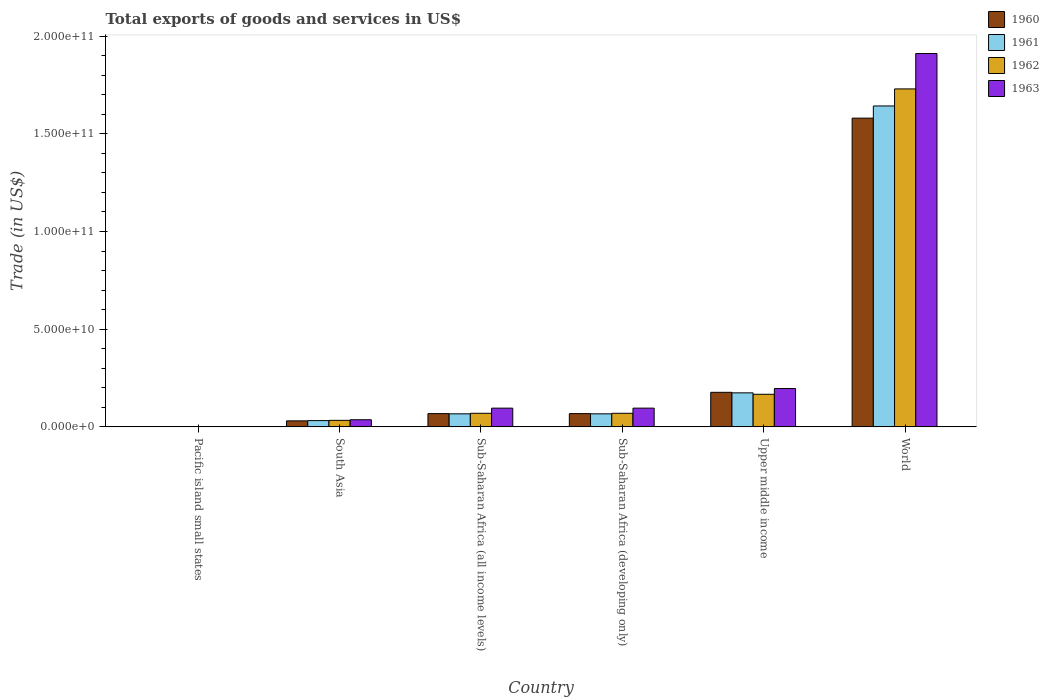How many different coloured bars are there?
Your response must be concise. 4. Are the number of bars per tick equal to the number of legend labels?
Your response must be concise. Yes. How many bars are there on the 2nd tick from the right?
Provide a succinct answer. 4. What is the label of the 6th group of bars from the left?
Ensure brevity in your answer.  World. In how many cases, is the number of bars for a given country not equal to the number of legend labels?
Your answer should be compact. 0. What is the total exports of goods and services in 1960 in South Asia?
Provide a succinct answer. 3.08e+09. Across all countries, what is the maximum total exports of goods and services in 1963?
Your answer should be very brief. 1.91e+11. Across all countries, what is the minimum total exports of goods and services in 1962?
Your answer should be compact. 6.29e+07. In which country was the total exports of goods and services in 1961 minimum?
Offer a very short reply. Pacific island small states. What is the total total exports of goods and services in 1960 in the graph?
Your answer should be very brief. 1.92e+11. What is the difference between the total exports of goods and services in 1962 in Pacific island small states and that in Sub-Saharan Africa (all income levels)?
Your answer should be compact. -6.89e+09. What is the difference between the total exports of goods and services in 1962 in Sub-Saharan Africa (all income levels) and the total exports of goods and services in 1963 in World?
Keep it short and to the point. -1.84e+11. What is the average total exports of goods and services in 1963 per country?
Your answer should be compact. 3.89e+1. What is the difference between the total exports of goods and services of/in 1963 and total exports of goods and services of/in 1960 in South Asia?
Your answer should be compact. 5.70e+08. In how many countries, is the total exports of goods and services in 1961 greater than 90000000000 US$?
Offer a terse response. 1. What is the ratio of the total exports of goods and services in 1960 in Sub-Saharan Africa (all income levels) to that in World?
Provide a short and direct response. 0.04. Is the total exports of goods and services in 1961 in Pacific island small states less than that in Upper middle income?
Make the answer very short. Yes. Is the difference between the total exports of goods and services in 1963 in Sub-Saharan Africa (all income levels) and Sub-Saharan Africa (developing only) greater than the difference between the total exports of goods and services in 1960 in Sub-Saharan Africa (all income levels) and Sub-Saharan Africa (developing only)?
Your answer should be very brief. No. What is the difference between the highest and the second highest total exports of goods and services in 1961?
Make the answer very short. -1.47e+11. What is the difference between the highest and the lowest total exports of goods and services in 1962?
Offer a very short reply. 1.73e+11. Is the sum of the total exports of goods and services in 1960 in Pacific island small states and South Asia greater than the maximum total exports of goods and services in 1963 across all countries?
Provide a short and direct response. No. Is it the case that in every country, the sum of the total exports of goods and services in 1960 and total exports of goods and services in 1963 is greater than the total exports of goods and services in 1962?
Provide a short and direct response. Yes. How many bars are there?
Your response must be concise. 24. Are all the bars in the graph horizontal?
Your answer should be compact. No. How many countries are there in the graph?
Offer a terse response. 6. Does the graph contain any zero values?
Provide a short and direct response. No. Where does the legend appear in the graph?
Offer a very short reply. Top right. How are the legend labels stacked?
Keep it short and to the point. Vertical. What is the title of the graph?
Make the answer very short. Total exports of goods and services in US$. What is the label or title of the X-axis?
Provide a short and direct response. Country. What is the label or title of the Y-axis?
Your response must be concise. Trade (in US$). What is the Trade (in US$) in 1960 in Pacific island small states?
Your answer should be compact. 6.15e+07. What is the Trade (in US$) in 1961 in Pacific island small states?
Offer a very short reply. 5.15e+07. What is the Trade (in US$) of 1962 in Pacific island small states?
Provide a short and direct response. 6.29e+07. What is the Trade (in US$) of 1963 in Pacific island small states?
Provide a short and direct response. 9.49e+07. What is the Trade (in US$) of 1960 in South Asia?
Your answer should be very brief. 3.08e+09. What is the Trade (in US$) of 1961 in South Asia?
Make the answer very short. 3.21e+09. What is the Trade (in US$) in 1962 in South Asia?
Give a very brief answer. 3.33e+09. What is the Trade (in US$) of 1963 in South Asia?
Your answer should be compact. 3.65e+09. What is the Trade (in US$) in 1960 in Sub-Saharan Africa (all income levels)?
Offer a very short reply. 6.78e+09. What is the Trade (in US$) of 1961 in Sub-Saharan Africa (all income levels)?
Keep it short and to the point. 6.67e+09. What is the Trade (in US$) in 1962 in Sub-Saharan Africa (all income levels)?
Keep it short and to the point. 6.95e+09. What is the Trade (in US$) in 1963 in Sub-Saharan Africa (all income levels)?
Provide a short and direct response. 9.58e+09. What is the Trade (in US$) of 1960 in Sub-Saharan Africa (developing only)?
Your answer should be compact. 6.78e+09. What is the Trade (in US$) in 1961 in Sub-Saharan Africa (developing only)?
Ensure brevity in your answer.  6.68e+09. What is the Trade (in US$) of 1962 in Sub-Saharan Africa (developing only)?
Keep it short and to the point. 6.95e+09. What is the Trade (in US$) in 1963 in Sub-Saharan Africa (developing only)?
Your answer should be very brief. 9.59e+09. What is the Trade (in US$) of 1960 in Upper middle income?
Offer a very short reply. 1.77e+1. What is the Trade (in US$) in 1961 in Upper middle income?
Give a very brief answer. 1.74e+1. What is the Trade (in US$) of 1962 in Upper middle income?
Provide a succinct answer. 1.67e+1. What is the Trade (in US$) of 1963 in Upper middle income?
Offer a very short reply. 1.96e+1. What is the Trade (in US$) in 1960 in World?
Provide a succinct answer. 1.58e+11. What is the Trade (in US$) of 1961 in World?
Keep it short and to the point. 1.64e+11. What is the Trade (in US$) in 1962 in World?
Your answer should be compact. 1.73e+11. What is the Trade (in US$) of 1963 in World?
Give a very brief answer. 1.91e+11. Across all countries, what is the maximum Trade (in US$) of 1960?
Make the answer very short. 1.58e+11. Across all countries, what is the maximum Trade (in US$) of 1961?
Ensure brevity in your answer.  1.64e+11. Across all countries, what is the maximum Trade (in US$) in 1962?
Offer a very short reply. 1.73e+11. Across all countries, what is the maximum Trade (in US$) in 1963?
Your answer should be compact. 1.91e+11. Across all countries, what is the minimum Trade (in US$) of 1960?
Your answer should be very brief. 6.15e+07. Across all countries, what is the minimum Trade (in US$) of 1961?
Offer a very short reply. 5.15e+07. Across all countries, what is the minimum Trade (in US$) of 1962?
Make the answer very short. 6.29e+07. Across all countries, what is the minimum Trade (in US$) of 1963?
Give a very brief answer. 9.49e+07. What is the total Trade (in US$) of 1960 in the graph?
Offer a very short reply. 1.92e+11. What is the total Trade (in US$) in 1961 in the graph?
Ensure brevity in your answer.  1.98e+11. What is the total Trade (in US$) in 1962 in the graph?
Provide a short and direct response. 2.07e+11. What is the total Trade (in US$) of 1963 in the graph?
Provide a short and direct response. 2.34e+11. What is the difference between the Trade (in US$) of 1960 in Pacific island small states and that in South Asia?
Your response must be concise. -3.01e+09. What is the difference between the Trade (in US$) in 1961 in Pacific island small states and that in South Asia?
Keep it short and to the point. -3.16e+09. What is the difference between the Trade (in US$) of 1962 in Pacific island small states and that in South Asia?
Offer a terse response. -3.27e+09. What is the difference between the Trade (in US$) of 1963 in Pacific island small states and that in South Asia?
Your answer should be compact. -3.55e+09. What is the difference between the Trade (in US$) in 1960 in Pacific island small states and that in Sub-Saharan Africa (all income levels)?
Make the answer very short. -6.72e+09. What is the difference between the Trade (in US$) of 1961 in Pacific island small states and that in Sub-Saharan Africa (all income levels)?
Keep it short and to the point. -6.62e+09. What is the difference between the Trade (in US$) in 1962 in Pacific island small states and that in Sub-Saharan Africa (all income levels)?
Offer a terse response. -6.89e+09. What is the difference between the Trade (in US$) in 1963 in Pacific island small states and that in Sub-Saharan Africa (all income levels)?
Make the answer very short. -9.49e+09. What is the difference between the Trade (in US$) in 1960 in Pacific island small states and that in Sub-Saharan Africa (developing only)?
Keep it short and to the point. -6.72e+09. What is the difference between the Trade (in US$) in 1961 in Pacific island small states and that in Sub-Saharan Africa (developing only)?
Your answer should be compact. -6.62e+09. What is the difference between the Trade (in US$) of 1962 in Pacific island small states and that in Sub-Saharan Africa (developing only)?
Offer a very short reply. -6.89e+09. What is the difference between the Trade (in US$) in 1963 in Pacific island small states and that in Sub-Saharan Africa (developing only)?
Keep it short and to the point. -9.49e+09. What is the difference between the Trade (in US$) in 1960 in Pacific island small states and that in Upper middle income?
Keep it short and to the point. -1.76e+1. What is the difference between the Trade (in US$) in 1961 in Pacific island small states and that in Upper middle income?
Give a very brief answer. -1.74e+1. What is the difference between the Trade (in US$) of 1962 in Pacific island small states and that in Upper middle income?
Offer a very short reply. -1.66e+1. What is the difference between the Trade (in US$) of 1963 in Pacific island small states and that in Upper middle income?
Your answer should be very brief. -1.95e+1. What is the difference between the Trade (in US$) of 1960 in Pacific island small states and that in World?
Your response must be concise. -1.58e+11. What is the difference between the Trade (in US$) of 1961 in Pacific island small states and that in World?
Your response must be concise. -1.64e+11. What is the difference between the Trade (in US$) in 1962 in Pacific island small states and that in World?
Provide a short and direct response. -1.73e+11. What is the difference between the Trade (in US$) of 1963 in Pacific island small states and that in World?
Offer a very short reply. -1.91e+11. What is the difference between the Trade (in US$) of 1960 in South Asia and that in Sub-Saharan Africa (all income levels)?
Provide a short and direct response. -3.71e+09. What is the difference between the Trade (in US$) in 1961 in South Asia and that in Sub-Saharan Africa (all income levels)?
Give a very brief answer. -3.47e+09. What is the difference between the Trade (in US$) in 1962 in South Asia and that in Sub-Saharan Africa (all income levels)?
Make the answer very short. -3.62e+09. What is the difference between the Trade (in US$) of 1963 in South Asia and that in Sub-Saharan Africa (all income levels)?
Offer a terse response. -5.94e+09. What is the difference between the Trade (in US$) of 1960 in South Asia and that in Sub-Saharan Africa (developing only)?
Make the answer very short. -3.71e+09. What is the difference between the Trade (in US$) of 1961 in South Asia and that in Sub-Saharan Africa (developing only)?
Give a very brief answer. -3.47e+09. What is the difference between the Trade (in US$) of 1962 in South Asia and that in Sub-Saharan Africa (developing only)?
Your answer should be compact. -3.62e+09. What is the difference between the Trade (in US$) of 1963 in South Asia and that in Sub-Saharan Africa (developing only)?
Make the answer very short. -5.94e+09. What is the difference between the Trade (in US$) in 1960 in South Asia and that in Upper middle income?
Your answer should be very brief. -1.46e+1. What is the difference between the Trade (in US$) in 1961 in South Asia and that in Upper middle income?
Make the answer very short. -1.42e+1. What is the difference between the Trade (in US$) in 1962 in South Asia and that in Upper middle income?
Your answer should be very brief. -1.33e+1. What is the difference between the Trade (in US$) in 1963 in South Asia and that in Upper middle income?
Offer a terse response. -1.60e+1. What is the difference between the Trade (in US$) of 1960 in South Asia and that in World?
Keep it short and to the point. -1.55e+11. What is the difference between the Trade (in US$) in 1961 in South Asia and that in World?
Offer a very short reply. -1.61e+11. What is the difference between the Trade (in US$) in 1962 in South Asia and that in World?
Give a very brief answer. -1.70e+11. What is the difference between the Trade (in US$) in 1963 in South Asia and that in World?
Provide a short and direct response. -1.87e+11. What is the difference between the Trade (in US$) of 1960 in Sub-Saharan Africa (all income levels) and that in Sub-Saharan Africa (developing only)?
Ensure brevity in your answer.  -1.83e+06. What is the difference between the Trade (in US$) of 1961 in Sub-Saharan Africa (all income levels) and that in Sub-Saharan Africa (developing only)?
Provide a short and direct response. -1.80e+06. What is the difference between the Trade (in US$) of 1962 in Sub-Saharan Africa (all income levels) and that in Sub-Saharan Africa (developing only)?
Ensure brevity in your answer.  -1.87e+06. What is the difference between the Trade (in US$) of 1963 in Sub-Saharan Africa (all income levels) and that in Sub-Saharan Africa (developing only)?
Offer a terse response. -4.80e+06. What is the difference between the Trade (in US$) of 1960 in Sub-Saharan Africa (all income levels) and that in Upper middle income?
Make the answer very short. -1.09e+1. What is the difference between the Trade (in US$) of 1961 in Sub-Saharan Africa (all income levels) and that in Upper middle income?
Your answer should be very brief. -1.07e+1. What is the difference between the Trade (in US$) of 1962 in Sub-Saharan Africa (all income levels) and that in Upper middle income?
Keep it short and to the point. -9.72e+09. What is the difference between the Trade (in US$) of 1963 in Sub-Saharan Africa (all income levels) and that in Upper middle income?
Give a very brief answer. -1.00e+1. What is the difference between the Trade (in US$) of 1960 in Sub-Saharan Africa (all income levels) and that in World?
Make the answer very short. -1.51e+11. What is the difference between the Trade (in US$) in 1961 in Sub-Saharan Africa (all income levels) and that in World?
Make the answer very short. -1.58e+11. What is the difference between the Trade (in US$) in 1962 in Sub-Saharan Africa (all income levels) and that in World?
Provide a succinct answer. -1.66e+11. What is the difference between the Trade (in US$) in 1963 in Sub-Saharan Africa (all income levels) and that in World?
Give a very brief answer. -1.81e+11. What is the difference between the Trade (in US$) of 1960 in Sub-Saharan Africa (developing only) and that in Upper middle income?
Provide a short and direct response. -1.09e+1. What is the difference between the Trade (in US$) of 1961 in Sub-Saharan Africa (developing only) and that in Upper middle income?
Ensure brevity in your answer.  -1.07e+1. What is the difference between the Trade (in US$) of 1962 in Sub-Saharan Africa (developing only) and that in Upper middle income?
Offer a very short reply. -9.72e+09. What is the difference between the Trade (in US$) of 1963 in Sub-Saharan Africa (developing only) and that in Upper middle income?
Provide a short and direct response. -1.00e+1. What is the difference between the Trade (in US$) of 1960 in Sub-Saharan Africa (developing only) and that in World?
Make the answer very short. -1.51e+11. What is the difference between the Trade (in US$) of 1961 in Sub-Saharan Africa (developing only) and that in World?
Keep it short and to the point. -1.58e+11. What is the difference between the Trade (in US$) in 1962 in Sub-Saharan Africa (developing only) and that in World?
Make the answer very short. -1.66e+11. What is the difference between the Trade (in US$) in 1963 in Sub-Saharan Africa (developing only) and that in World?
Your response must be concise. -1.81e+11. What is the difference between the Trade (in US$) of 1960 in Upper middle income and that in World?
Ensure brevity in your answer.  -1.40e+11. What is the difference between the Trade (in US$) of 1961 in Upper middle income and that in World?
Provide a short and direct response. -1.47e+11. What is the difference between the Trade (in US$) in 1962 in Upper middle income and that in World?
Your answer should be very brief. -1.56e+11. What is the difference between the Trade (in US$) of 1963 in Upper middle income and that in World?
Your answer should be very brief. -1.71e+11. What is the difference between the Trade (in US$) of 1960 in Pacific island small states and the Trade (in US$) of 1961 in South Asia?
Offer a terse response. -3.15e+09. What is the difference between the Trade (in US$) of 1960 in Pacific island small states and the Trade (in US$) of 1962 in South Asia?
Offer a very short reply. -3.27e+09. What is the difference between the Trade (in US$) in 1960 in Pacific island small states and the Trade (in US$) in 1963 in South Asia?
Ensure brevity in your answer.  -3.58e+09. What is the difference between the Trade (in US$) of 1961 in Pacific island small states and the Trade (in US$) of 1962 in South Asia?
Keep it short and to the point. -3.28e+09. What is the difference between the Trade (in US$) of 1961 in Pacific island small states and the Trade (in US$) of 1963 in South Asia?
Give a very brief answer. -3.59e+09. What is the difference between the Trade (in US$) in 1962 in Pacific island small states and the Trade (in US$) in 1963 in South Asia?
Provide a short and direct response. -3.58e+09. What is the difference between the Trade (in US$) in 1960 in Pacific island small states and the Trade (in US$) in 1961 in Sub-Saharan Africa (all income levels)?
Ensure brevity in your answer.  -6.61e+09. What is the difference between the Trade (in US$) of 1960 in Pacific island small states and the Trade (in US$) of 1962 in Sub-Saharan Africa (all income levels)?
Keep it short and to the point. -6.89e+09. What is the difference between the Trade (in US$) in 1960 in Pacific island small states and the Trade (in US$) in 1963 in Sub-Saharan Africa (all income levels)?
Give a very brief answer. -9.52e+09. What is the difference between the Trade (in US$) of 1961 in Pacific island small states and the Trade (in US$) of 1962 in Sub-Saharan Africa (all income levels)?
Your answer should be very brief. -6.90e+09. What is the difference between the Trade (in US$) in 1961 in Pacific island small states and the Trade (in US$) in 1963 in Sub-Saharan Africa (all income levels)?
Your response must be concise. -9.53e+09. What is the difference between the Trade (in US$) in 1962 in Pacific island small states and the Trade (in US$) in 1963 in Sub-Saharan Africa (all income levels)?
Offer a terse response. -9.52e+09. What is the difference between the Trade (in US$) of 1960 in Pacific island small states and the Trade (in US$) of 1961 in Sub-Saharan Africa (developing only)?
Provide a succinct answer. -6.61e+09. What is the difference between the Trade (in US$) in 1960 in Pacific island small states and the Trade (in US$) in 1962 in Sub-Saharan Africa (developing only)?
Keep it short and to the point. -6.89e+09. What is the difference between the Trade (in US$) in 1960 in Pacific island small states and the Trade (in US$) in 1963 in Sub-Saharan Africa (developing only)?
Provide a short and direct response. -9.53e+09. What is the difference between the Trade (in US$) in 1961 in Pacific island small states and the Trade (in US$) in 1962 in Sub-Saharan Africa (developing only)?
Your answer should be very brief. -6.90e+09. What is the difference between the Trade (in US$) in 1961 in Pacific island small states and the Trade (in US$) in 1963 in Sub-Saharan Africa (developing only)?
Provide a short and direct response. -9.54e+09. What is the difference between the Trade (in US$) of 1962 in Pacific island small states and the Trade (in US$) of 1963 in Sub-Saharan Africa (developing only)?
Provide a short and direct response. -9.52e+09. What is the difference between the Trade (in US$) of 1960 in Pacific island small states and the Trade (in US$) of 1961 in Upper middle income?
Ensure brevity in your answer.  -1.74e+1. What is the difference between the Trade (in US$) in 1960 in Pacific island small states and the Trade (in US$) in 1962 in Upper middle income?
Keep it short and to the point. -1.66e+1. What is the difference between the Trade (in US$) in 1960 in Pacific island small states and the Trade (in US$) in 1963 in Upper middle income?
Offer a terse response. -1.96e+1. What is the difference between the Trade (in US$) in 1961 in Pacific island small states and the Trade (in US$) in 1962 in Upper middle income?
Give a very brief answer. -1.66e+1. What is the difference between the Trade (in US$) of 1961 in Pacific island small states and the Trade (in US$) of 1963 in Upper middle income?
Your answer should be very brief. -1.96e+1. What is the difference between the Trade (in US$) of 1962 in Pacific island small states and the Trade (in US$) of 1963 in Upper middle income?
Give a very brief answer. -1.96e+1. What is the difference between the Trade (in US$) of 1960 in Pacific island small states and the Trade (in US$) of 1961 in World?
Provide a short and direct response. -1.64e+11. What is the difference between the Trade (in US$) of 1960 in Pacific island small states and the Trade (in US$) of 1962 in World?
Keep it short and to the point. -1.73e+11. What is the difference between the Trade (in US$) of 1960 in Pacific island small states and the Trade (in US$) of 1963 in World?
Your answer should be very brief. -1.91e+11. What is the difference between the Trade (in US$) of 1961 in Pacific island small states and the Trade (in US$) of 1962 in World?
Your answer should be compact. -1.73e+11. What is the difference between the Trade (in US$) of 1961 in Pacific island small states and the Trade (in US$) of 1963 in World?
Provide a succinct answer. -1.91e+11. What is the difference between the Trade (in US$) in 1962 in Pacific island small states and the Trade (in US$) in 1963 in World?
Your answer should be compact. -1.91e+11. What is the difference between the Trade (in US$) in 1960 in South Asia and the Trade (in US$) in 1961 in Sub-Saharan Africa (all income levels)?
Make the answer very short. -3.60e+09. What is the difference between the Trade (in US$) in 1960 in South Asia and the Trade (in US$) in 1962 in Sub-Saharan Africa (all income levels)?
Offer a terse response. -3.88e+09. What is the difference between the Trade (in US$) in 1960 in South Asia and the Trade (in US$) in 1963 in Sub-Saharan Africa (all income levels)?
Your answer should be very brief. -6.51e+09. What is the difference between the Trade (in US$) of 1961 in South Asia and the Trade (in US$) of 1962 in Sub-Saharan Africa (all income levels)?
Your answer should be very brief. -3.74e+09. What is the difference between the Trade (in US$) of 1961 in South Asia and the Trade (in US$) of 1963 in Sub-Saharan Africa (all income levels)?
Provide a short and direct response. -6.37e+09. What is the difference between the Trade (in US$) in 1962 in South Asia and the Trade (in US$) in 1963 in Sub-Saharan Africa (all income levels)?
Your answer should be compact. -6.25e+09. What is the difference between the Trade (in US$) in 1960 in South Asia and the Trade (in US$) in 1961 in Sub-Saharan Africa (developing only)?
Ensure brevity in your answer.  -3.60e+09. What is the difference between the Trade (in US$) in 1960 in South Asia and the Trade (in US$) in 1962 in Sub-Saharan Africa (developing only)?
Your answer should be very brief. -3.88e+09. What is the difference between the Trade (in US$) in 1960 in South Asia and the Trade (in US$) in 1963 in Sub-Saharan Africa (developing only)?
Make the answer very short. -6.51e+09. What is the difference between the Trade (in US$) in 1961 in South Asia and the Trade (in US$) in 1962 in Sub-Saharan Africa (developing only)?
Ensure brevity in your answer.  -3.75e+09. What is the difference between the Trade (in US$) in 1961 in South Asia and the Trade (in US$) in 1963 in Sub-Saharan Africa (developing only)?
Offer a terse response. -6.38e+09. What is the difference between the Trade (in US$) of 1962 in South Asia and the Trade (in US$) of 1963 in Sub-Saharan Africa (developing only)?
Give a very brief answer. -6.25e+09. What is the difference between the Trade (in US$) in 1960 in South Asia and the Trade (in US$) in 1961 in Upper middle income?
Make the answer very short. -1.43e+1. What is the difference between the Trade (in US$) of 1960 in South Asia and the Trade (in US$) of 1962 in Upper middle income?
Provide a succinct answer. -1.36e+1. What is the difference between the Trade (in US$) of 1960 in South Asia and the Trade (in US$) of 1963 in Upper middle income?
Make the answer very short. -1.65e+1. What is the difference between the Trade (in US$) in 1961 in South Asia and the Trade (in US$) in 1962 in Upper middle income?
Your response must be concise. -1.35e+1. What is the difference between the Trade (in US$) in 1961 in South Asia and the Trade (in US$) in 1963 in Upper middle income?
Your answer should be compact. -1.64e+1. What is the difference between the Trade (in US$) of 1962 in South Asia and the Trade (in US$) of 1963 in Upper middle income?
Make the answer very short. -1.63e+1. What is the difference between the Trade (in US$) in 1960 in South Asia and the Trade (in US$) in 1961 in World?
Make the answer very short. -1.61e+11. What is the difference between the Trade (in US$) in 1960 in South Asia and the Trade (in US$) in 1962 in World?
Offer a terse response. -1.70e+11. What is the difference between the Trade (in US$) in 1960 in South Asia and the Trade (in US$) in 1963 in World?
Your answer should be compact. -1.88e+11. What is the difference between the Trade (in US$) in 1961 in South Asia and the Trade (in US$) in 1962 in World?
Make the answer very short. -1.70e+11. What is the difference between the Trade (in US$) of 1961 in South Asia and the Trade (in US$) of 1963 in World?
Your answer should be very brief. -1.88e+11. What is the difference between the Trade (in US$) in 1962 in South Asia and the Trade (in US$) in 1963 in World?
Keep it short and to the point. -1.88e+11. What is the difference between the Trade (in US$) of 1960 in Sub-Saharan Africa (all income levels) and the Trade (in US$) of 1961 in Sub-Saharan Africa (developing only)?
Give a very brief answer. 1.06e+08. What is the difference between the Trade (in US$) in 1960 in Sub-Saharan Africa (all income levels) and the Trade (in US$) in 1962 in Sub-Saharan Africa (developing only)?
Your response must be concise. -1.73e+08. What is the difference between the Trade (in US$) in 1960 in Sub-Saharan Africa (all income levels) and the Trade (in US$) in 1963 in Sub-Saharan Africa (developing only)?
Your response must be concise. -2.81e+09. What is the difference between the Trade (in US$) of 1961 in Sub-Saharan Africa (all income levels) and the Trade (in US$) of 1962 in Sub-Saharan Africa (developing only)?
Provide a short and direct response. -2.81e+08. What is the difference between the Trade (in US$) in 1961 in Sub-Saharan Africa (all income levels) and the Trade (in US$) in 1963 in Sub-Saharan Africa (developing only)?
Your answer should be very brief. -2.91e+09. What is the difference between the Trade (in US$) in 1962 in Sub-Saharan Africa (all income levels) and the Trade (in US$) in 1963 in Sub-Saharan Africa (developing only)?
Offer a very short reply. -2.63e+09. What is the difference between the Trade (in US$) in 1960 in Sub-Saharan Africa (all income levels) and the Trade (in US$) in 1961 in Upper middle income?
Provide a succinct answer. -1.06e+1. What is the difference between the Trade (in US$) in 1960 in Sub-Saharan Africa (all income levels) and the Trade (in US$) in 1962 in Upper middle income?
Your answer should be very brief. -9.89e+09. What is the difference between the Trade (in US$) in 1960 in Sub-Saharan Africa (all income levels) and the Trade (in US$) in 1963 in Upper middle income?
Your answer should be very brief. -1.28e+1. What is the difference between the Trade (in US$) of 1961 in Sub-Saharan Africa (all income levels) and the Trade (in US$) of 1962 in Upper middle income?
Your response must be concise. -1.00e+1. What is the difference between the Trade (in US$) in 1961 in Sub-Saharan Africa (all income levels) and the Trade (in US$) in 1963 in Upper middle income?
Give a very brief answer. -1.29e+1. What is the difference between the Trade (in US$) of 1962 in Sub-Saharan Africa (all income levels) and the Trade (in US$) of 1963 in Upper middle income?
Your response must be concise. -1.27e+1. What is the difference between the Trade (in US$) in 1960 in Sub-Saharan Africa (all income levels) and the Trade (in US$) in 1961 in World?
Your answer should be compact. -1.57e+11. What is the difference between the Trade (in US$) in 1960 in Sub-Saharan Africa (all income levels) and the Trade (in US$) in 1962 in World?
Ensure brevity in your answer.  -1.66e+11. What is the difference between the Trade (in US$) of 1960 in Sub-Saharan Africa (all income levels) and the Trade (in US$) of 1963 in World?
Provide a succinct answer. -1.84e+11. What is the difference between the Trade (in US$) in 1961 in Sub-Saharan Africa (all income levels) and the Trade (in US$) in 1962 in World?
Your answer should be very brief. -1.66e+11. What is the difference between the Trade (in US$) of 1961 in Sub-Saharan Africa (all income levels) and the Trade (in US$) of 1963 in World?
Ensure brevity in your answer.  -1.84e+11. What is the difference between the Trade (in US$) in 1962 in Sub-Saharan Africa (all income levels) and the Trade (in US$) in 1963 in World?
Provide a short and direct response. -1.84e+11. What is the difference between the Trade (in US$) of 1960 in Sub-Saharan Africa (developing only) and the Trade (in US$) of 1961 in Upper middle income?
Make the answer very short. -1.06e+1. What is the difference between the Trade (in US$) in 1960 in Sub-Saharan Africa (developing only) and the Trade (in US$) in 1962 in Upper middle income?
Keep it short and to the point. -9.89e+09. What is the difference between the Trade (in US$) in 1960 in Sub-Saharan Africa (developing only) and the Trade (in US$) in 1963 in Upper middle income?
Keep it short and to the point. -1.28e+1. What is the difference between the Trade (in US$) of 1961 in Sub-Saharan Africa (developing only) and the Trade (in US$) of 1962 in Upper middle income?
Your response must be concise. -1.00e+1. What is the difference between the Trade (in US$) of 1961 in Sub-Saharan Africa (developing only) and the Trade (in US$) of 1963 in Upper middle income?
Ensure brevity in your answer.  -1.29e+1. What is the difference between the Trade (in US$) of 1962 in Sub-Saharan Africa (developing only) and the Trade (in US$) of 1963 in Upper middle income?
Provide a short and direct response. -1.27e+1. What is the difference between the Trade (in US$) of 1960 in Sub-Saharan Africa (developing only) and the Trade (in US$) of 1961 in World?
Your answer should be compact. -1.57e+11. What is the difference between the Trade (in US$) of 1960 in Sub-Saharan Africa (developing only) and the Trade (in US$) of 1962 in World?
Keep it short and to the point. -1.66e+11. What is the difference between the Trade (in US$) in 1960 in Sub-Saharan Africa (developing only) and the Trade (in US$) in 1963 in World?
Give a very brief answer. -1.84e+11. What is the difference between the Trade (in US$) in 1961 in Sub-Saharan Africa (developing only) and the Trade (in US$) in 1962 in World?
Make the answer very short. -1.66e+11. What is the difference between the Trade (in US$) in 1961 in Sub-Saharan Africa (developing only) and the Trade (in US$) in 1963 in World?
Offer a very short reply. -1.84e+11. What is the difference between the Trade (in US$) in 1962 in Sub-Saharan Africa (developing only) and the Trade (in US$) in 1963 in World?
Give a very brief answer. -1.84e+11. What is the difference between the Trade (in US$) in 1960 in Upper middle income and the Trade (in US$) in 1961 in World?
Keep it short and to the point. -1.47e+11. What is the difference between the Trade (in US$) in 1960 in Upper middle income and the Trade (in US$) in 1962 in World?
Keep it short and to the point. -1.55e+11. What is the difference between the Trade (in US$) in 1960 in Upper middle income and the Trade (in US$) in 1963 in World?
Your answer should be compact. -1.73e+11. What is the difference between the Trade (in US$) of 1961 in Upper middle income and the Trade (in US$) of 1962 in World?
Provide a short and direct response. -1.56e+11. What is the difference between the Trade (in US$) of 1961 in Upper middle income and the Trade (in US$) of 1963 in World?
Offer a very short reply. -1.74e+11. What is the difference between the Trade (in US$) in 1962 in Upper middle income and the Trade (in US$) in 1963 in World?
Ensure brevity in your answer.  -1.74e+11. What is the average Trade (in US$) in 1960 per country?
Ensure brevity in your answer.  3.21e+1. What is the average Trade (in US$) of 1961 per country?
Your answer should be compact. 3.30e+1. What is the average Trade (in US$) of 1962 per country?
Your answer should be very brief. 3.45e+1. What is the average Trade (in US$) of 1963 per country?
Make the answer very short. 3.89e+1. What is the difference between the Trade (in US$) in 1960 and Trade (in US$) in 1961 in Pacific island small states?
Make the answer very short. 9.94e+06. What is the difference between the Trade (in US$) of 1960 and Trade (in US$) of 1962 in Pacific island small states?
Provide a succinct answer. -1.45e+06. What is the difference between the Trade (in US$) of 1960 and Trade (in US$) of 1963 in Pacific island small states?
Your response must be concise. -3.35e+07. What is the difference between the Trade (in US$) of 1961 and Trade (in US$) of 1962 in Pacific island small states?
Your answer should be compact. -1.14e+07. What is the difference between the Trade (in US$) of 1961 and Trade (in US$) of 1963 in Pacific island small states?
Offer a terse response. -4.34e+07. What is the difference between the Trade (in US$) of 1962 and Trade (in US$) of 1963 in Pacific island small states?
Keep it short and to the point. -3.20e+07. What is the difference between the Trade (in US$) of 1960 and Trade (in US$) of 1961 in South Asia?
Provide a short and direct response. -1.32e+08. What is the difference between the Trade (in US$) in 1960 and Trade (in US$) in 1962 in South Asia?
Your response must be concise. -2.57e+08. What is the difference between the Trade (in US$) in 1960 and Trade (in US$) in 1963 in South Asia?
Offer a terse response. -5.70e+08. What is the difference between the Trade (in US$) of 1961 and Trade (in US$) of 1962 in South Asia?
Provide a short and direct response. -1.26e+08. What is the difference between the Trade (in US$) of 1961 and Trade (in US$) of 1963 in South Asia?
Give a very brief answer. -4.38e+08. What is the difference between the Trade (in US$) in 1962 and Trade (in US$) in 1963 in South Asia?
Provide a short and direct response. -3.13e+08. What is the difference between the Trade (in US$) in 1960 and Trade (in US$) in 1961 in Sub-Saharan Africa (all income levels)?
Your answer should be compact. 1.08e+08. What is the difference between the Trade (in US$) in 1960 and Trade (in US$) in 1962 in Sub-Saharan Africa (all income levels)?
Keep it short and to the point. -1.71e+08. What is the difference between the Trade (in US$) of 1960 and Trade (in US$) of 1963 in Sub-Saharan Africa (all income levels)?
Make the answer very short. -2.80e+09. What is the difference between the Trade (in US$) of 1961 and Trade (in US$) of 1962 in Sub-Saharan Africa (all income levels)?
Offer a terse response. -2.79e+08. What is the difference between the Trade (in US$) of 1961 and Trade (in US$) of 1963 in Sub-Saharan Africa (all income levels)?
Give a very brief answer. -2.91e+09. What is the difference between the Trade (in US$) of 1962 and Trade (in US$) of 1963 in Sub-Saharan Africa (all income levels)?
Offer a very short reply. -2.63e+09. What is the difference between the Trade (in US$) of 1960 and Trade (in US$) of 1961 in Sub-Saharan Africa (developing only)?
Your response must be concise. 1.08e+08. What is the difference between the Trade (in US$) in 1960 and Trade (in US$) in 1962 in Sub-Saharan Africa (developing only)?
Your response must be concise. -1.71e+08. What is the difference between the Trade (in US$) of 1960 and Trade (in US$) of 1963 in Sub-Saharan Africa (developing only)?
Keep it short and to the point. -2.80e+09. What is the difference between the Trade (in US$) in 1961 and Trade (in US$) in 1962 in Sub-Saharan Africa (developing only)?
Provide a short and direct response. -2.79e+08. What is the difference between the Trade (in US$) of 1961 and Trade (in US$) of 1963 in Sub-Saharan Africa (developing only)?
Ensure brevity in your answer.  -2.91e+09. What is the difference between the Trade (in US$) of 1962 and Trade (in US$) of 1963 in Sub-Saharan Africa (developing only)?
Keep it short and to the point. -2.63e+09. What is the difference between the Trade (in US$) in 1960 and Trade (in US$) in 1961 in Upper middle income?
Offer a terse response. 2.71e+08. What is the difference between the Trade (in US$) of 1960 and Trade (in US$) of 1962 in Upper middle income?
Your answer should be compact. 1.01e+09. What is the difference between the Trade (in US$) in 1960 and Trade (in US$) in 1963 in Upper middle income?
Give a very brief answer. -1.93e+09. What is the difference between the Trade (in US$) in 1961 and Trade (in US$) in 1962 in Upper middle income?
Keep it short and to the point. 7.39e+08. What is the difference between the Trade (in US$) of 1961 and Trade (in US$) of 1963 in Upper middle income?
Give a very brief answer. -2.21e+09. What is the difference between the Trade (in US$) in 1962 and Trade (in US$) in 1963 in Upper middle income?
Keep it short and to the point. -2.95e+09. What is the difference between the Trade (in US$) of 1960 and Trade (in US$) of 1961 in World?
Keep it short and to the point. -6.23e+09. What is the difference between the Trade (in US$) of 1960 and Trade (in US$) of 1962 in World?
Make the answer very short. -1.50e+1. What is the difference between the Trade (in US$) in 1960 and Trade (in US$) in 1963 in World?
Offer a terse response. -3.31e+1. What is the difference between the Trade (in US$) of 1961 and Trade (in US$) of 1962 in World?
Provide a short and direct response. -8.73e+09. What is the difference between the Trade (in US$) in 1961 and Trade (in US$) in 1963 in World?
Offer a terse response. -2.68e+1. What is the difference between the Trade (in US$) of 1962 and Trade (in US$) of 1963 in World?
Keep it short and to the point. -1.81e+1. What is the ratio of the Trade (in US$) of 1961 in Pacific island small states to that in South Asia?
Your answer should be compact. 0.02. What is the ratio of the Trade (in US$) in 1962 in Pacific island small states to that in South Asia?
Provide a succinct answer. 0.02. What is the ratio of the Trade (in US$) of 1963 in Pacific island small states to that in South Asia?
Make the answer very short. 0.03. What is the ratio of the Trade (in US$) of 1960 in Pacific island small states to that in Sub-Saharan Africa (all income levels)?
Provide a succinct answer. 0.01. What is the ratio of the Trade (in US$) of 1961 in Pacific island small states to that in Sub-Saharan Africa (all income levels)?
Keep it short and to the point. 0.01. What is the ratio of the Trade (in US$) in 1962 in Pacific island small states to that in Sub-Saharan Africa (all income levels)?
Your answer should be very brief. 0.01. What is the ratio of the Trade (in US$) of 1963 in Pacific island small states to that in Sub-Saharan Africa (all income levels)?
Ensure brevity in your answer.  0.01. What is the ratio of the Trade (in US$) of 1960 in Pacific island small states to that in Sub-Saharan Africa (developing only)?
Make the answer very short. 0.01. What is the ratio of the Trade (in US$) of 1961 in Pacific island small states to that in Sub-Saharan Africa (developing only)?
Your response must be concise. 0.01. What is the ratio of the Trade (in US$) of 1962 in Pacific island small states to that in Sub-Saharan Africa (developing only)?
Keep it short and to the point. 0.01. What is the ratio of the Trade (in US$) in 1963 in Pacific island small states to that in Sub-Saharan Africa (developing only)?
Provide a short and direct response. 0.01. What is the ratio of the Trade (in US$) in 1960 in Pacific island small states to that in Upper middle income?
Offer a very short reply. 0. What is the ratio of the Trade (in US$) in 1961 in Pacific island small states to that in Upper middle income?
Provide a short and direct response. 0. What is the ratio of the Trade (in US$) of 1962 in Pacific island small states to that in Upper middle income?
Ensure brevity in your answer.  0. What is the ratio of the Trade (in US$) of 1963 in Pacific island small states to that in Upper middle income?
Provide a succinct answer. 0. What is the ratio of the Trade (in US$) of 1961 in Pacific island small states to that in World?
Your response must be concise. 0. What is the ratio of the Trade (in US$) of 1962 in Pacific island small states to that in World?
Your answer should be very brief. 0. What is the ratio of the Trade (in US$) in 1963 in Pacific island small states to that in World?
Give a very brief answer. 0. What is the ratio of the Trade (in US$) in 1960 in South Asia to that in Sub-Saharan Africa (all income levels)?
Make the answer very short. 0.45. What is the ratio of the Trade (in US$) in 1961 in South Asia to that in Sub-Saharan Africa (all income levels)?
Ensure brevity in your answer.  0.48. What is the ratio of the Trade (in US$) of 1962 in South Asia to that in Sub-Saharan Africa (all income levels)?
Make the answer very short. 0.48. What is the ratio of the Trade (in US$) in 1963 in South Asia to that in Sub-Saharan Africa (all income levels)?
Your answer should be very brief. 0.38. What is the ratio of the Trade (in US$) of 1960 in South Asia to that in Sub-Saharan Africa (developing only)?
Your answer should be compact. 0.45. What is the ratio of the Trade (in US$) in 1961 in South Asia to that in Sub-Saharan Africa (developing only)?
Your response must be concise. 0.48. What is the ratio of the Trade (in US$) of 1962 in South Asia to that in Sub-Saharan Africa (developing only)?
Offer a terse response. 0.48. What is the ratio of the Trade (in US$) of 1963 in South Asia to that in Sub-Saharan Africa (developing only)?
Your answer should be compact. 0.38. What is the ratio of the Trade (in US$) of 1960 in South Asia to that in Upper middle income?
Give a very brief answer. 0.17. What is the ratio of the Trade (in US$) of 1961 in South Asia to that in Upper middle income?
Make the answer very short. 0.18. What is the ratio of the Trade (in US$) of 1962 in South Asia to that in Upper middle income?
Keep it short and to the point. 0.2. What is the ratio of the Trade (in US$) of 1963 in South Asia to that in Upper middle income?
Provide a short and direct response. 0.19. What is the ratio of the Trade (in US$) in 1960 in South Asia to that in World?
Your answer should be very brief. 0.02. What is the ratio of the Trade (in US$) in 1961 in South Asia to that in World?
Offer a terse response. 0.02. What is the ratio of the Trade (in US$) in 1962 in South Asia to that in World?
Keep it short and to the point. 0.02. What is the ratio of the Trade (in US$) of 1963 in South Asia to that in World?
Offer a very short reply. 0.02. What is the ratio of the Trade (in US$) in 1960 in Sub-Saharan Africa (all income levels) to that in Sub-Saharan Africa (developing only)?
Give a very brief answer. 1. What is the ratio of the Trade (in US$) of 1961 in Sub-Saharan Africa (all income levels) to that in Sub-Saharan Africa (developing only)?
Your answer should be very brief. 1. What is the ratio of the Trade (in US$) in 1963 in Sub-Saharan Africa (all income levels) to that in Sub-Saharan Africa (developing only)?
Give a very brief answer. 1. What is the ratio of the Trade (in US$) of 1960 in Sub-Saharan Africa (all income levels) to that in Upper middle income?
Ensure brevity in your answer.  0.38. What is the ratio of the Trade (in US$) in 1961 in Sub-Saharan Africa (all income levels) to that in Upper middle income?
Ensure brevity in your answer.  0.38. What is the ratio of the Trade (in US$) of 1962 in Sub-Saharan Africa (all income levels) to that in Upper middle income?
Provide a short and direct response. 0.42. What is the ratio of the Trade (in US$) in 1963 in Sub-Saharan Africa (all income levels) to that in Upper middle income?
Your response must be concise. 0.49. What is the ratio of the Trade (in US$) in 1960 in Sub-Saharan Africa (all income levels) to that in World?
Your response must be concise. 0.04. What is the ratio of the Trade (in US$) of 1961 in Sub-Saharan Africa (all income levels) to that in World?
Offer a very short reply. 0.04. What is the ratio of the Trade (in US$) in 1962 in Sub-Saharan Africa (all income levels) to that in World?
Give a very brief answer. 0.04. What is the ratio of the Trade (in US$) in 1963 in Sub-Saharan Africa (all income levels) to that in World?
Your answer should be very brief. 0.05. What is the ratio of the Trade (in US$) of 1960 in Sub-Saharan Africa (developing only) to that in Upper middle income?
Your answer should be compact. 0.38. What is the ratio of the Trade (in US$) of 1961 in Sub-Saharan Africa (developing only) to that in Upper middle income?
Your response must be concise. 0.38. What is the ratio of the Trade (in US$) in 1962 in Sub-Saharan Africa (developing only) to that in Upper middle income?
Provide a short and direct response. 0.42. What is the ratio of the Trade (in US$) in 1963 in Sub-Saharan Africa (developing only) to that in Upper middle income?
Your answer should be compact. 0.49. What is the ratio of the Trade (in US$) of 1960 in Sub-Saharan Africa (developing only) to that in World?
Make the answer very short. 0.04. What is the ratio of the Trade (in US$) of 1961 in Sub-Saharan Africa (developing only) to that in World?
Make the answer very short. 0.04. What is the ratio of the Trade (in US$) of 1962 in Sub-Saharan Africa (developing only) to that in World?
Give a very brief answer. 0.04. What is the ratio of the Trade (in US$) of 1963 in Sub-Saharan Africa (developing only) to that in World?
Your answer should be very brief. 0.05. What is the ratio of the Trade (in US$) in 1960 in Upper middle income to that in World?
Keep it short and to the point. 0.11. What is the ratio of the Trade (in US$) in 1961 in Upper middle income to that in World?
Offer a very short reply. 0.11. What is the ratio of the Trade (in US$) in 1962 in Upper middle income to that in World?
Your answer should be compact. 0.1. What is the ratio of the Trade (in US$) in 1963 in Upper middle income to that in World?
Offer a terse response. 0.1. What is the difference between the highest and the second highest Trade (in US$) in 1960?
Give a very brief answer. 1.40e+11. What is the difference between the highest and the second highest Trade (in US$) in 1961?
Keep it short and to the point. 1.47e+11. What is the difference between the highest and the second highest Trade (in US$) of 1962?
Make the answer very short. 1.56e+11. What is the difference between the highest and the second highest Trade (in US$) of 1963?
Make the answer very short. 1.71e+11. What is the difference between the highest and the lowest Trade (in US$) of 1960?
Give a very brief answer. 1.58e+11. What is the difference between the highest and the lowest Trade (in US$) in 1961?
Provide a succinct answer. 1.64e+11. What is the difference between the highest and the lowest Trade (in US$) in 1962?
Offer a terse response. 1.73e+11. What is the difference between the highest and the lowest Trade (in US$) of 1963?
Give a very brief answer. 1.91e+11. 